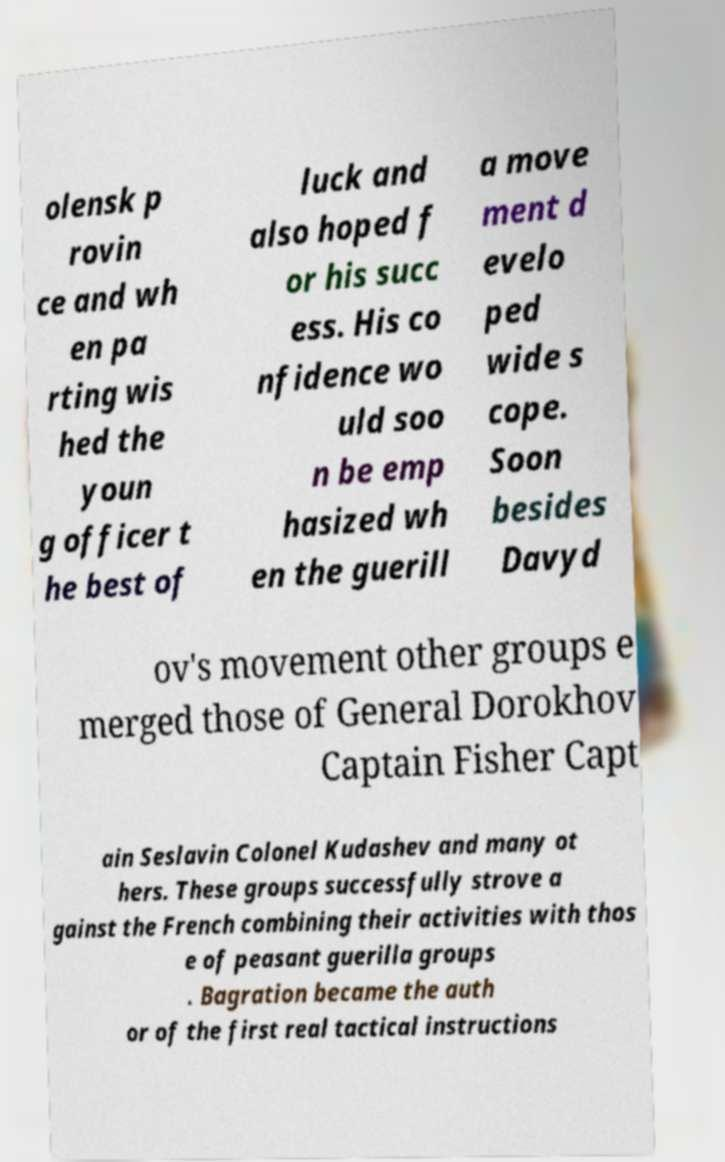Please identify and transcribe the text found in this image. olensk p rovin ce and wh en pa rting wis hed the youn g officer t he best of luck and also hoped f or his succ ess. His co nfidence wo uld soo n be emp hasized wh en the guerill a move ment d evelo ped wide s cope. Soon besides Davyd ov's movement other groups e merged those of General Dorokhov Captain Fisher Capt ain Seslavin Colonel Kudashev and many ot hers. These groups successfully strove a gainst the French combining their activities with thos e of peasant guerilla groups . Bagration became the auth or of the first real tactical instructions 